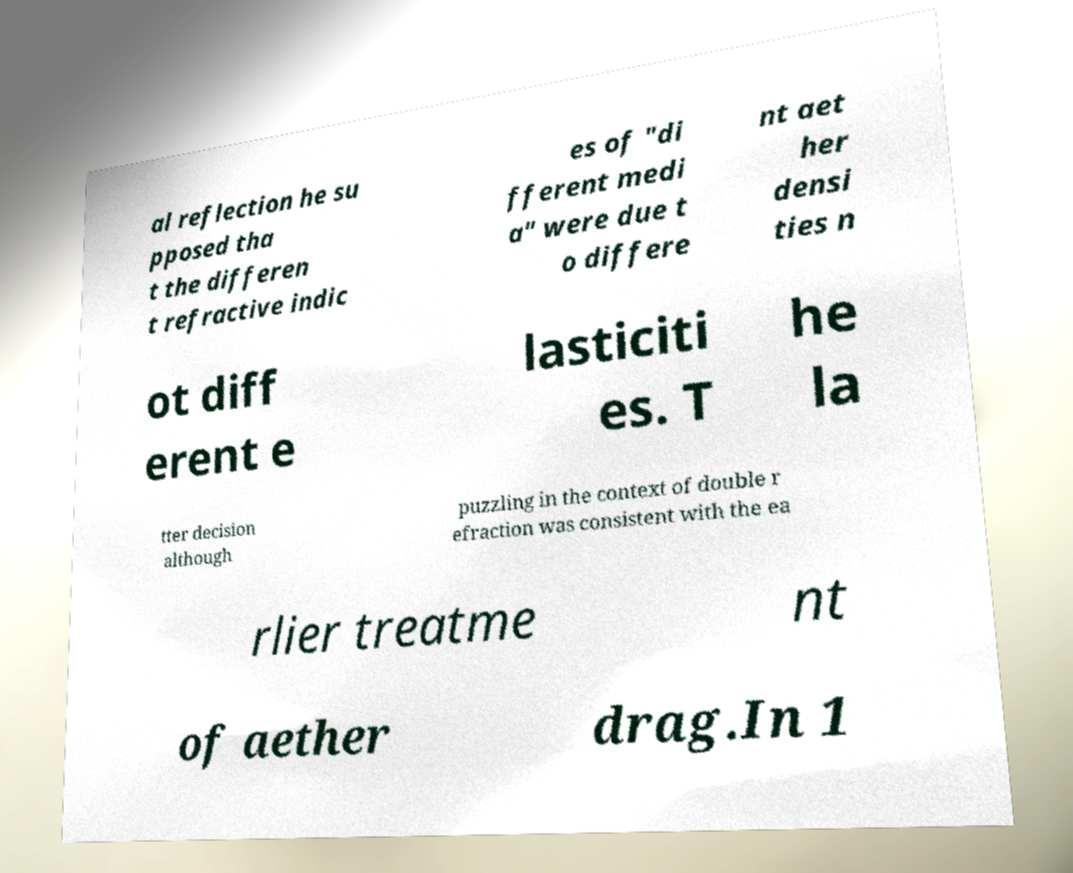What messages or text are displayed in this image? I need them in a readable, typed format. al reflection he su pposed tha t the differen t refractive indic es of "di fferent medi a" were due t o differe nt aet her densi ties n ot diff erent e lasticiti es. T he la tter decision although puzzling in the context of double r efraction was consistent with the ea rlier treatme nt of aether drag.In 1 